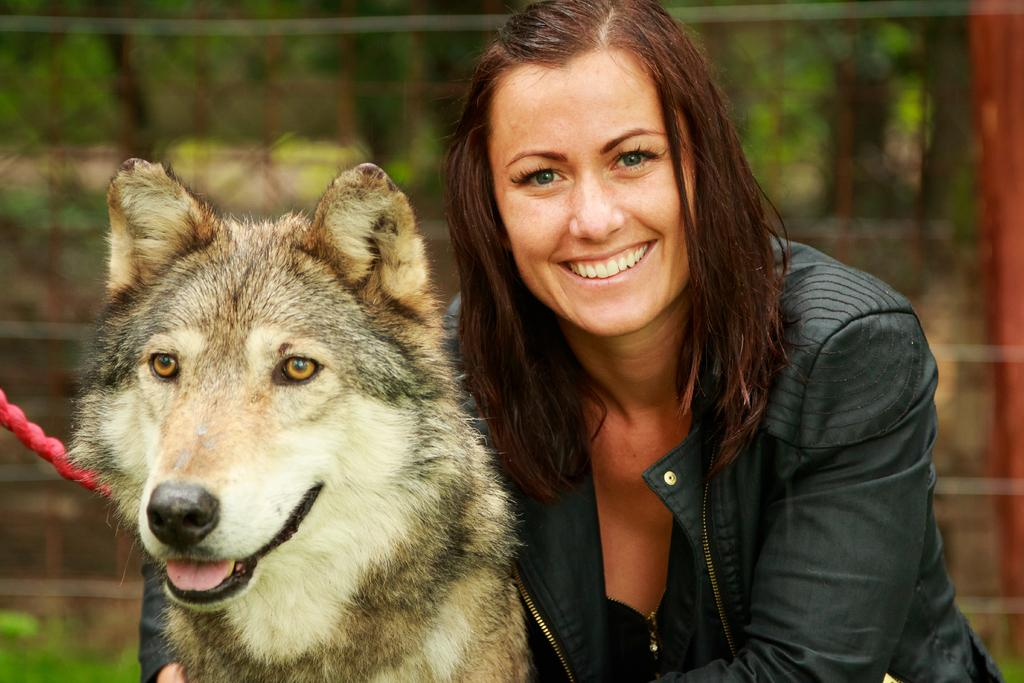Who is present in the image? There is a woman in the image. What is the woman wearing? The woman is wearing a black dress. What other living creature is in the image? There is a dog in the image. Can you describe the appearance of the dog? The dog has white, brown, and black colors. What can be observed about the background of the image? The background of the image is blurred. What type of plastic is the snail using to slide across the floor in the image? There is no snail or plastic present in the image. 